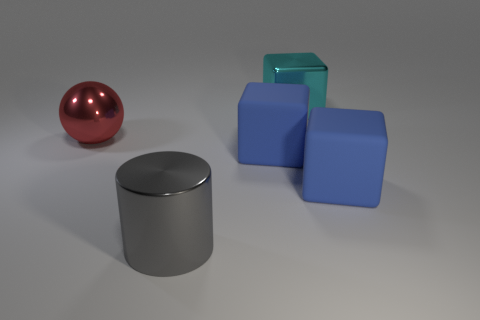Subtract all blue blocks. How many blocks are left? 1 Add 2 big matte objects. How many objects exist? 7 Add 1 cyan metallic objects. How many cyan metallic objects are left? 2 Add 1 tiny brown metallic cubes. How many tiny brown metallic cubes exist? 1 Subtract all blue blocks. How many blocks are left? 1 Subtract 0 brown balls. How many objects are left? 5 Subtract all cylinders. How many objects are left? 4 Subtract 1 blocks. How many blocks are left? 2 Subtract all blue cylinders. Subtract all green spheres. How many cylinders are left? 1 Subtract all cyan balls. How many blue blocks are left? 2 